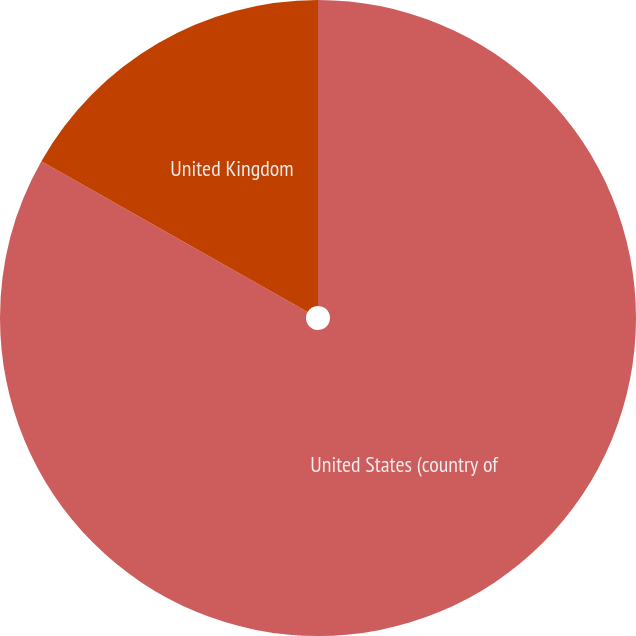<chart> <loc_0><loc_0><loc_500><loc_500><pie_chart><fcel>United States (country of<fcel>United Kingdom<nl><fcel>83.21%<fcel>16.79%<nl></chart> 